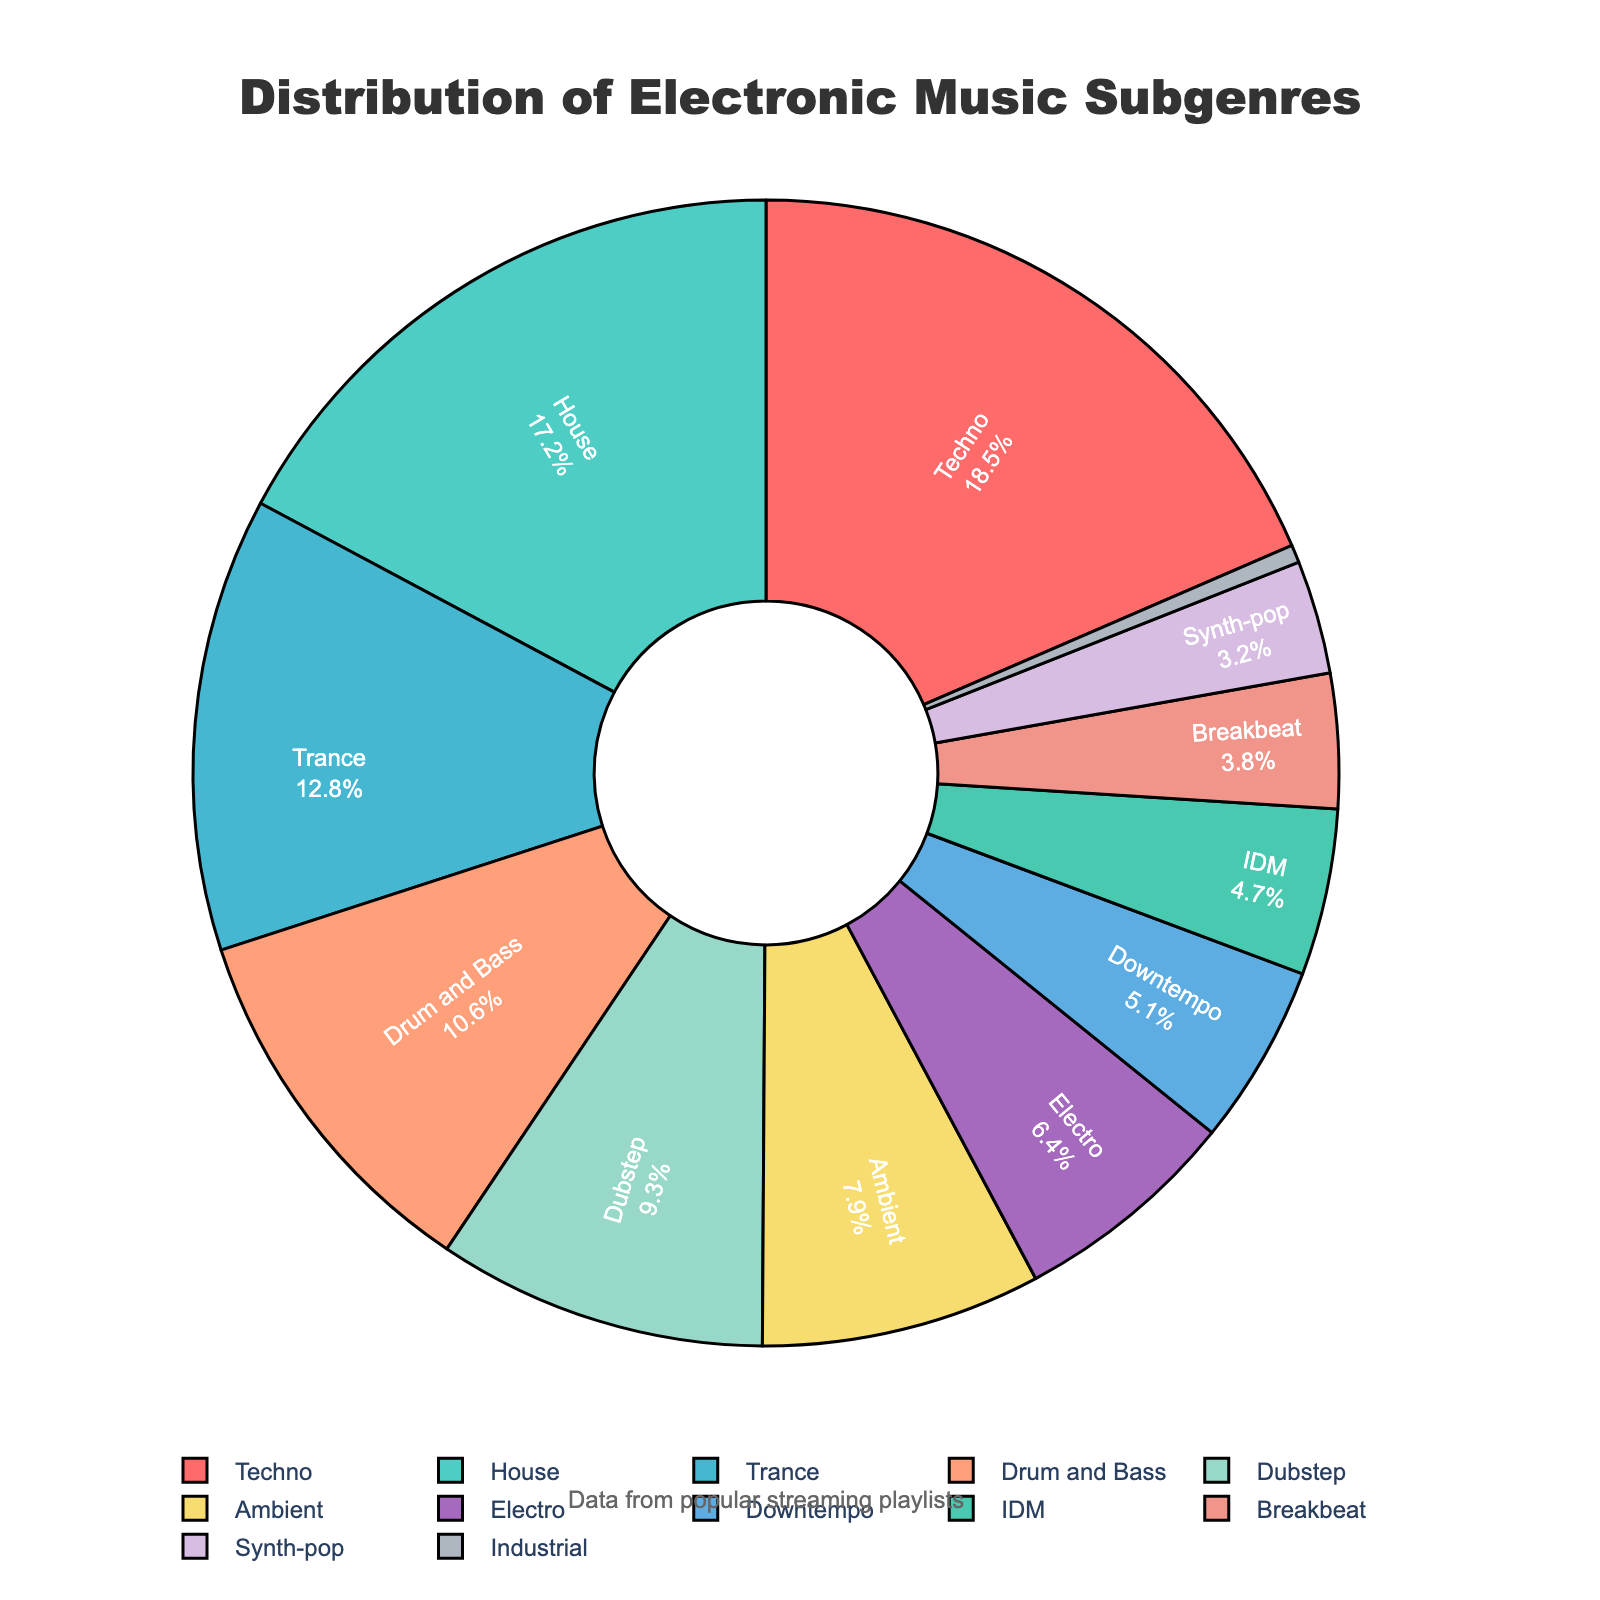What's the most popular electronic music subgenre in the streaming playlists? The chart shows that Techno has the largest slice, representing the highest percentage.
Answer: Techno Which subgenre has the smallest share in the playlists? The smallest slice in the chart is for Industrial, which represents 0.5%.
Answer: Industrial How much more popular is House than Ambient? House has a 17.2% share, while Ambient has a 7.9% share. The difference is 17.2 - 7.9 = 9.3%.
Answer: 9.3% What is the combined percentage of Techno, House, and Trance? The percentages for Techno, House, and Trance are 18.5%, 17.2%, and 12.8%, respectively. Adding them together gives 18.5 + 17.2 + 12.8 = 48.5%.
Answer: 48.5% Which has a larger share: Dubstep or Drum and Bass? Drum and Bass has a 10.6% share and Dubstep has a 9.3% share. Drum and Bass has the larger share.
Answer: Drum and Bass How many subgenres have a share greater than or equal to 10%? The subgenres Techno (18.5%), House (17.2%), Trance (12.8%), and Drum and Bass (10.6%) each have percentages greater than or equal to 10%.
Answer: 4 What is the difference in percentage between IDM and Breakbeat? IDM has a 4.7% share and Breakbeat has a 3.8% share. The difference is 4.7 - 3.8 = 0.9%.
Answer: 0.9% Which subgenres have similar sizes in the chart based on their percentages? Downtempo (5.1%) and IDM (4.7%) have similar sizes in the chart, with a difference of just 0.4%.
Answer: Downtempo and IDM What percentage do the less common subgenres (below 5% share) make up altogether? The less common subgenres are Industrial (0.5%), Synth-pop (3.2%), and Breakbeat (3.8%), which sum up to 0.5 + 3.2 + 3.8 = 7.5%.
Answer: 7.5% Are there any subgenres with almost equal percentages? Dubstep (9.3%) and Electro (6.4%) are not equal but relatively close percentages.
Answer: Dubstep and Electro 